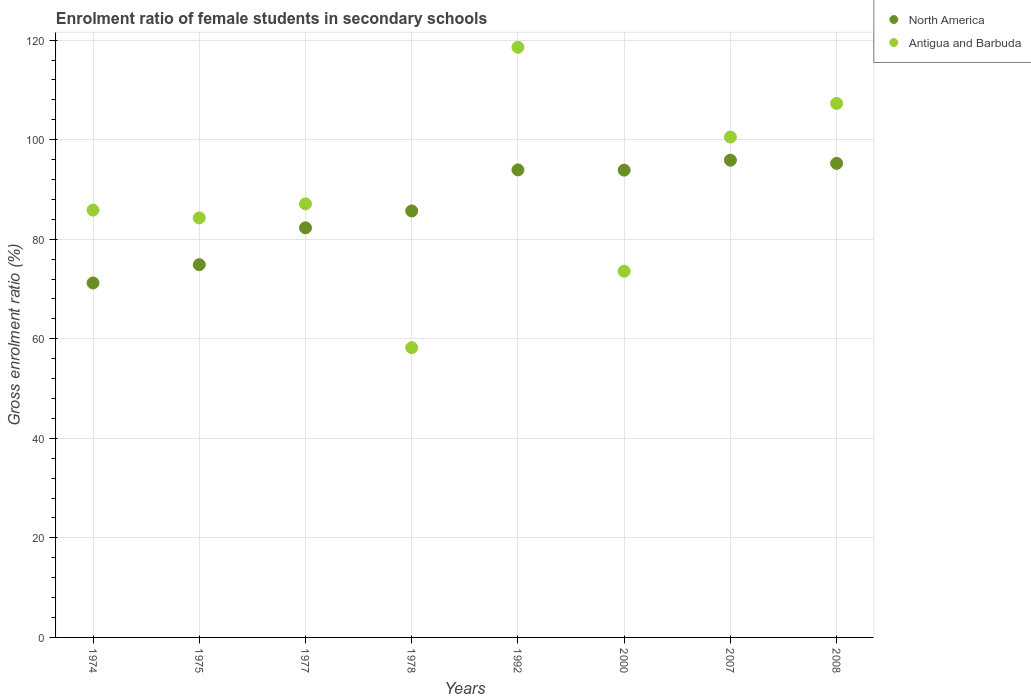Is the number of dotlines equal to the number of legend labels?
Your answer should be very brief. Yes. What is the enrolment ratio of female students in secondary schools in Antigua and Barbuda in 1977?
Your answer should be compact. 87.11. Across all years, what is the maximum enrolment ratio of female students in secondary schools in Antigua and Barbuda?
Offer a very short reply. 118.57. Across all years, what is the minimum enrolment ratio of female students in secondary schools in Antigua and Barbuda?
Give a very brief answer. 58.22. In which year was the enrolment ratio of female students in secondary schools in North America maximum?
Offer a terse response. 2007. In which year was the enrolment ratio of female students in secondary schools in Antigua and Barbuda minimum?
Make the answer very short. 1978. What is the total enrolment ratio of female students in secondary schools in North America in the graph?
Offer a very short reply. 693.03. What is the difference between the enrolment ratio of female students in secondary schools in Antigua and Barbuda in 1977 and that in 1992?
Your response must be concise. -31.46. What is the difference between the enrolment ratio of female students in secondary schools in North America in 1978 and the enrolment ratio of female students in secondary schools in Antigua and Barbuda in 1977?
Offer a terse response. -1.43. What is the average enrolment ratio of female students in secondary schools in Antigua and Barbuda per year?
Your response must be concise. 89.43. In the year 2008, what is the difference between the enrolment ratio of female students in secondary schools in Antigua and Barbuda and enrolment ratio of female students in secondary schools in North America?
Provide a short and direct response. 12.04. In how many years, is the enrolment ratio of female students in secondary schools in North America greater than 40 %?
Make the answer very short. 8. What is the ratio of the enrolment ratio of female students in secondary schools in North America in 1992 to that in 2000?
Provide a short and direct response. 1. Is the difference between the enrolment ratio of female students in secondary schools in Antigua and Barbuda in 1978 and 2007 greater than the difference between the enrolment ratio of female students in secondary schools in North America in 1978 and 2007?
Provide a short and direct response. No. What is the difference between the highest and the second highest enrolment ratio of female students in secondary schools in North America?
Make the answer very short. 0.64. What is the difference between the highest and the lowest enrolment ratio of female students in secondary schools in Antigua and Barbuda?
Provide a short and direct response. 60.35. In how many years, is the enrolment ratio of female students in secondary schools in Antigua and Barbuda greater than the average enrolment ratio of female students in secondary schools in Antigua and Barbuda taken over all years?
Offer a very short reply. 3. Is the enrolment ratio of female students in secondary schools in Antigua and Barbuda strictly less than the enrolment ratio of female students in secondary schools in North America over the years?
Give a very brief answer. No. How many years are there in the graph?
Keep it short and to the point. 8. What is the difference between two consecutive major ticks on the Y-axis?
Provide a short and direct response. 20. Are the values on the major ticks of Y-axis written in scientific E-notation?
Make the answer very short. No. Does the graph contain any zero values?
Ensure brevity in your answer.  No. Does the graph contain grids?
Give a very brief answer. Yes. How many legend labels are there?
Ensure brevity in your answer.  2. How are the legend labels stacked?
Offer a terse response. Vertical. What is the title of the graph?
Offer a terse response. Enrolment ratio of female students in secondary schools. Does "Montenegro" appear as one of the legend labels in the graph?
Your answer should be very brief. No. What is the label or title of the X-axis?
Your answer should be very brief. Years. What is the label or title of the Y-axis?
Make the answer very short. Gross enrolment ratio (%). What is the Gross enrolment ratio (%) in North America in 1974?
Offer a very short reply. 71.22. What is the Gross enrolment ratio (%) in Antigua and Barbuda in 1974?
Ensure brevity in your answer.  85.86. What is the Gross enrolment ratio (%) in North America in 1975?
Offer a very short reply. 74.89. What is the Gross enrolment ratio (%) of Antigua and Barbuda in 1975?
Offer a terse response. 84.29. What is the Gross enrolment ratio (%) of North America in 1977?
Provide a short and direct response. 82.29. What is the Gross enrolment ratio (%) of Antigua and Barbuda in 1977?
Offer a terse response. 87.11. What is the Gross enrolment ratio (%) of North America in 1978?
Keep it short and to the point. 85.68. What is the Gross enrolment ratio (%) in Antigua and Barbuda in 1978?
Keep it short and to the point. 58.22. What is the Gross enrolment ratio (%) in North America in 1992?
Give a very brief answer. 93.93. What is the Gross enrolment ratio (%) of Antigua and Barbuda in 1992?
Provide a short and direct response. 118.57. What is the Gross enrolment ratio (%) in North America in 2000?
Offer a very short reply. 93.89. What is the Gross enrolment ratio (%) of Antigua and Barbuda in 2000?
Provide a succinct answer. 73.58. What is the Gross enrolment ratio (%) in North America in 2007?
Offer a terse response. 95.88. What is the Gross enrolment ratio (%) of Antigua and Barbuda in 2007?
Your answer should be very brief. 100.53. What is the Gross enrolment ratio (%) in North America in 2008?
Provide a short and direct response. 95.24. What is the Gross enrolment ratio (%) in Antigua and Barbuda in 2008?
Offer a very short reply. 107.28. Across all years, what is the maximum Gross enrolment ratio (%) in North America?
Provide a succinct answer. 95.88. Across all years, what is the maximum Gross enrolment ratio (%) in Antigua and Barbuda?
Give a very brief answer. 118.57. Across all years, what is the minimum Gross enrolment ratio (%) in North America?
Provide a succinct answer. 71.22. Across all years, what is the minimum Gross enrolment ratio (%) of Antigua and Barbuda?
Your answer should be very brief. 58.22. What is the total Gross enrolment ratio (%) in North America in the graph?
Make the answer very short. 693.03. What is the total Gross enrolment ratio (%) in Antigua and Barbuda in the graph?
Make the answer very short. 715.44. What is the difference between the Gross enrolment ratio (%) in North America in 1974 and that in 1975?
Keep it short and to the point. -3.67. What is the difference between the Gross enrolment ratio (%) in Antigua and Barbuda in 1974 and that in 1975?
Give a very brief answer. 1.57. What is the difference between the Gross enrolment ratio (%) in North America in 1974 and that in 1977?
Keep it short and to the point. -11.08. What is the difference between the Gross enrolment ratio (%) in Antigua and Barbuda in 1974 and that in 1977?
Offer a very short reply. -1.25. What is the difference between the Gross enrolment ratio (%) in North America in 1974 and that in 1978?
Make the answer very short. -14.47. What is the difference between the Gross enrolment ratio (%) in Antigua and Barbuda in 1974 and that in 1978?
Your response must be concise. 27.64. What is the difference between the Gross enrolment ratio (%) in North America in 1974 and that in 1992?
Your response must be concise. -22.72. What is the difference between the Gross enrolment ratio (%) of Antigua and Barbuda in 1974 and that in 1992?
Ensure brevity in your answer.  -32.71. What is the difference between the Gross enrolment ratio (%) of North America in 1974 and that in 2000?
Your answer should be very brief. -22.67. What is the difference between the Gross enrolment ratio (%) of Antigua and Barbuda in 1974 and that in 2000?
Your response must be concise. 12.28. What is the difference between the Gross enrolment ratio (%) in North America in 1974 and that in 2007?
Your answer should be compact. -24.67. What is the difference between the Gross enrolment ratio (%) in Antigua and Barbuda in 1974 and that in 2007?
Ensure brevity in your answer.  -14.67. What is the difference between the Gross enrolment ratio (%) in North America in 1974 and that in 2008?
Your answer should be very brief. -24.03. What is the difference between the Gross enrolment ratio (%) in Antigua and Barbuda in 1974 and that in 2008?
Your answer should be very brief. -21.42. What is the difference between the Gross enrolment ratio (%) of North America in 1975 and that in 1977?
Keep it short and to the point. -7.4. What is the difference between the Gross enrolment ratio (%) of Antigua and Barbuda in 1975 and that in 1977?
Your answer should be very brief. -2.82. What is the difference between the Gross enrolment ratio (%) of North America in 1975 and that in 1978?
Provide a succinct answer. -10.79. What is the difference between the Gross enrolment ratio (%) in Antigua and Barbuda in 1975 and that in 1978?
Offer a terse response. 26.07. What is the difference between the Gross enrolment ratio (%) of North America in 1975 and that in 1992?
Make the answer very short. -19.04. What is the difference between the Gross enrolment ratio (%) of Antigua and Barbuda in 1975 and that in 1992?
Give a very brief answer. -34.28. What is the difference between the Gross enrolment ratio (%) in North America in 1975 and that in 2000?
Offer a very short reply. -19. What is the difference between the Gross enrolment ratio (%) of Antigua and Barbuda in 1975 and that in 2000?
Your response must be concise. 10.71. What is the difference between the Gross enrolment ratio (%) of North America in 1975 and that in 2007?
Provide a short and direct response. -20.99. What is the difference between the Gross enrolment ratio (%) in Antigua and Barbuda in 1975 and that in 2007?
Give a very brief answer. -16.24. What is the difference between the Gross enrolment ratio (%) in North America in 1975 and that in 2008?
Provide a short and direct response. -20.35. What is the difference between the Gross enrolment ratio (%) in Antigua and Barbuda in 1975 and that in 2008?
Make the answer very short. -23. What is the difference between the Gross enrolment ratio (%) in North America in 1977 and that in 1978?
Offer a very short reply. -3.39. What is the difference between the Gross enrolment ratio (%) of Antigua and Barbuda in 1977 and that in 1978?
Ensure brevity in your answer.  28.89. What is the difference between the Gross enrolment ratio (%) in North America in 1977 and that in 1992?
Offer a very short reply. -11.64. What is the difference between the Gross enrolment ratio (%) of Antigua and Barbuda in 1977 and that in 1992?
Provide a short and direct response. -31.46. What is the difference between the Gross enrolment ratio (%) of North America in 1977 and that in 2000?
Provide a short and direct response. -11.59. What is the difference between the Gross enrolment ratio (%) in Antigua and Barbuda in 1977 and that in 2000?
Make the answer very short. 13.53. What is the difference between the Gross enrolment ratio (%) in North America in 1977 and that in 2007?
Offer a very short reply. -13.59. What is the difference between the Gross enrolment ratio (%) in Antigua and Barbuda in 1977 and that in 2007?
Provide a succinct answer. -13.42. What is the difference between the Gross enrolment ratio (%) of North America in 1977 and that in 2008?
Your response must be concise. -12.95. What is the difference between the Gross enrolment ratio (%) in Antigua and Barbuda in 1977 and that in 2008?
Give a very brief answer. -20.18. What is the difference between the Gross enrolment ratio (%) of North America in 1978 and that in 1992?
Provide a short and direct response. -8.25. What is the difference between the Gross enrolment ratio (%) of Antigua and Barbuda in 1978 and that in 1992?
Ensure brevity in your answer.  -60.35. What is the difference between the Gross enrolment ratio (%) of North America in 1978 and that in 2000?
Keep it short and to the point. -8.2. What is the difference between the Gross enrolment ratio (%) of Antigua and Barbuda in 1978 and that in 2000?
Keep it short and to the point. -15.36. What is the difference between the Gross enrolment ratio (%) in North America in 1978 and that in 2007?
Keep it short and to the point. -10.2. What is the difference between the Gross enrolment ratio (%) in Antigua and Barbuda in 1978 and that in 2007?
Your response must be concise. -42.3. What is the difference between the Gross enrolment ratio (%) in North America in 1978 and that in 2008?
Offer a terse response. -9.56. What is the difference between the Gross enrolment ratio (%) of Antigua and Barbuda in 1978 and that in 2008?
Provide a short and direct response. -49.06. What is the difference between the Gross enrolment ratio (%) of North America in 1992 and that in 2000?
Your answer should be compact. 0.05. What is the difference between the Gross enrolment ratio (%) in Antigua and Barbuda in 1992 and that in 2000?
Your answer should be very brief. 44.99. What is the difference between the Gross enrolment ratio (%) in North America in 1992 and that in 2007?
Keep it short and to the point. -1.95. What is the difference between the Gross enrolment ratio (%) of Antigua and Barbuda in 1992 and that in 2007?
Provide a succinct answer. 18.04. What is the difference between the Gross enrolment ratio (%) of North America in 1992 and that in 2008?
Offer a very short reply. -1.31. What is the difference between the Gross enrolment ratio (%) of Antigua and Barbuda in 1992 and that in 2008?
Offer a terse response. 11.29. What is the difference between the Gross enrolment ratio (%) in North America in 2000 and that in 2007?
Your response must be concise. -2. What is the difference between the Gross enrolment ratio (%) in Antigua and Barbuda in 2000 and that in 2007?
Provide a succinct answer. -26.95. What is the difference between the Gross enrolment ratio (%) of North America in 2000 and that in 2008?
Ensure brevity in your answer.  -1.36. What is the difference between the Gross enrolment ratio (%) in Antigua and Barbuda in 2000 and that in 2008?
Offer a terse response. -33.71. What is the difference between the Gross enrolment ratio (%) of North America in 2007 and that in 2008?
Ensure brevity in your answer.  0.64. What is the difference between the Gross enrolment ratio (%) of Antigua and Barbuda in 2007 and that in 2008?
Make the answer very short. -6.76. What is the difference between the Gross enrolment ratio (%) in North America in 1974 and the Gross enrolment ratio (%) in Antigua and Barbuda in 1975?
Provide a succinct answer. -13.07. What is the difference between the Gross enrolment ratio (%) in North America in 1974 and the Gross enrolment ratio (%) in Antigua and Barbuda in 1977?
Make the answer very short. -15.89. What is the difference between the Gross enrolment ratio (%) of North America in 1974 and the Gross enrolment ratio (%) of Antigua and Barbuda in 1978?
Keep it short and to the point. 12.99. What is the difference between the Gross enrolment ratio (%) of North America in 1974 and the Gross enrolment ratio (%) of Antigua and Barbuda in 1992?
Your response must be concise. -47.36. What is the difference between the Gross enrolment ratio (%) in North America in 1974 and the Gross enrolment ratio (%) in Antigua and Barbuda in 2000?
Provide a short and direct response. -2.36. What is the difference between the Gross enrolment ratio (%) of North America in 1974 and the Gross enrolment ratio (%) of Antigua and Barbuda in 2007?
Provide a succinct answer. -29.31. What is the difference between the Gross enrolment ratio (%) of North America in 1974 and the Gross enrolment ratio (%) of Antigua and Barbuda in 2008?
Your response must be concise. -36.07. What is the difference between the Gross enrolment ratio (%) in North America in 1975 and the Gross enrolment ratio (%) in Antigua and Barbuda in 1977?
Provide a succinct answer. -12.22. What is the difference between the Gross enrolment ratio (%) of North America in 1975 and the Gross enrolment ratio (%) of Antigua and Barbuda in 1978?
Your response must be concise. 16.67. What is the difference between the Gross enrolment ratio (%) in North America in 1975 and the Gross enrolment ratio (%) in Antigua and Barbuda in 1992?
Keep it short and to the point. -43.68. What is the difference between the Gross enrolment ratio (%) of North America in 1975 and the Gross enrolment ratio (%) of Antigua and Barbuda in 2000?
Offer a very short reply. 1.31. What is the difference between the Gross enrolment ratio (%) of North America in 1975 and the Gross enrolment ratio (%) of Antigua and Barbuda in 2007?
Provide a succinct answer. -25.64. What is the difference between the Gross enrolment ratio (%) of North America in 1975 and the Gross enrolment ratio (%) of Antigua and Barbuda in 2008?
Ensure brevity in your answer.  -32.4. What is the difference between the Gross enrolment ratio (%) of North America in 1977 and the Gross enrolment ratio (%) of Antigua and Barbuda in 1978?
Offer a terse response. 24.07. What is the difference between the Gross enrolment ratio (%) of North America in 1977 and the Gross enrolment ratio (%) of Antigua and Barbuda in 1992?
Provide a succinct answer. -36.28. What is the difference between the Gross enrolment ratio (%) in North America in 1977 and the Gross enrolment ratio (%) in Antigua and Barbuda in 2000?
Provide a succinct answer. 8.72. What is the difference between the Gross enrolment ratio (%) in North America in 1977 and the Gross enrolment ratio (%) in Antigua and Barbuda in 2007?
Your answer should be very brief. -18.23. What is the difference between the Gross enrolment ratio (%) in North America in 1977 and the Gross enrolment ratio (%) in Antigua and Barbuda in 2008?
Keep it short and to the point. -24.99. What is the difference between the Gross enrolment ratio (%) in North America in 1978 and the Gross enrolment ratio (%) in Antigua and Barbuda in 1992?
Provide a short and direct response. -32.89. What is the difference between the Gross enrolment ratio (%) in North America in 1978 and the Gross enrolment ratio (%) in Antigua and Barbuda in 2000?
Your answer should be very brief. 12.1. What is the difference between the Gross enrolment ratio (%) of North America in 1978 and the Gross enrolment ratio (%) of Antigua and Barbuda in 2007?
Your response must be concise. -14.85. What is the difference between the Gross enrolment ratio (%) of North America in 1978 and the Gross enrolment ratio (%) of Antigua and Barbuda in 2008?
Keep it short and to the point. -21.6. What is the difference between the Gross enrolment ratio (%) in North America in 1992 and the Gross enrolment ratio (%) in Antigua and Barbuda in 2000?
Give a very brief answer. 20.36. What is the difference between the Gross enrolment ratio (%) in North America in 1992 and the Gross enrolment ratio (%) in Antigua and Barbuda in 2007?
Offer a terse response. -6.59. What is the difference between the Gross enrolment ratio (%) in North America in 1992 and the Gross enrolment ratio (%) in Antigua and Barbuda in 2008?
Offer a terse response. -13.35. What is the difference between the Gross enrolment ratio (%) of North America in 2000 and the Gross enrolment ratio (%) of Antigua and Barbuda in 2007?
Give a very brief answer. -6.64. What is the difference between the Gross enrolment ratio (%) in North America in 2000 and the Gross enrolment ratio (%) in Antigua and Barbuda in 2008?
Make the answer very short. -13.4. What is the difference between the Gross enrolment ratio (%) in North America in 2007 and the Gross enrolment ratio (%) in Antigua and Barbuda in 2008?
Your answer should be very brief. -11.4. What is the average Gross enrolment ratio (%) in North America per year?
Offer a terse response. 86.63. What is the average Gross enrolment ratio (%) of Antigua and Barbuda per year?
Your answer should be very brief. 89.43. In the year 1974, what is the difference between the Gross enrolment ratio (%) of North America and Gross enrolment ratio (%) of Antigua and Barbuda?
Provide a succinct answer. -14.64. In the year 1975, what is the difference between the Gross enrolment ratio (%) of North America and Gross enrolment ratio (%) of Antigua and Barbuda?
Your answer should be compact. -9.4. In the year 1977, what is the difference between the Gross enrolment ratio (%) of North America and Gross enrolment ratio (%) of Antigua and Barbuda?
Ensure brevity in your answer.  -4.81. In the year 1978, what is the difference between the Gross enrolment ratio (%) in North America and Gross enrolment ratio (%) in Antigua and Barbuda?
Keep it short and to the point. 27.46. In the year 1992, what is the difference between the Gross enrolment ratio (%) of North America and Gross enrolment ratio (%) of Antigua and Barbuda?
Your response must be concise. -24.64. In the year 2000, what is the difference between the Gross enrolment ratio (%) of North America and Gross enrolment ratio (%) of Antigua and Barbuda?
Keep it short and to the point. 20.31. In the year 2007, what is the difference between the Gross enrolment ratio (%) in North America and Gross enrolment ratio (%) in Antigua and Barbuda?
Offer a terse response. -4.64. In the year 2008, what is the difference between the Gross enrolment ratio (%) in North America and Gross enrolment ratio (%) in Antigua and Barbuda?
Provide a short and direct response. -12.04. What is the ratio of the Gross enrolment ratio (%) in North America in 1974 to that in 1975?
Give a very brief answer. 0.95. What is the ratio of the Gross enrolment ratio (%) in Antigua and Barbuda in 1974 to that in 1975?
Keep it short and to the point. 1.02. What is the ratio of the Gross enrolment ratio (%) in North America in 1974 to that in 1977?
Provide a short and direct response. 0.87. What is the ratio of the Gross enrolment ratio (%) in Antigua and Barbuda in 1974 to that in 1977?
Provide a succinct answer. 0.99. What is the ratio of the Gross enrolment ratio (%) of North America in 1974 to that in 1978?
Give a very brief answer. 0.83. What is the ratio of the Gross enrolment ratio (%) in Antigua and Barbuda in 1974 to that in 1978?
Provide a succinct answer. 1.47. What is the ratio of the Gross enrolment ratio (%) of North America in 1974 to that in 1992?
Provide a short and direct response. 0.76. What is the ratio of the Gross enrolment ratio (%) in Antigua and Barbuda in 1974 to that in 1992?
Give a very brief answer. 0.72. What is the ratio of the Gross enrolment ratio (%) of North America in 1974 to that in 2000?
Give a very brief answer. 0.76. What is the ratio of the Gross enrolment ratio (%) of Antigua and Barbuda in 1974 to that in 2000?
Offer a very short reply. 1.17. What is the ratio of the Gross enrolment ratio (%) of North America in 1974 to that in 2007?
Your answer should be very brief. 0.74. What is the ratio of the Gross enrolment ratio (%) in Antigua and Barbuda in 1974 to that in 2007?
Your response must be concise. 0.85. What is the ratio of the Gross enrolment ratio (%) in North America in 1974 to that in 2008?
Keep it short and to the point. 0.75. What is the ratio of the Gross enrolment ratio (%) in Antigua and Barbuda in 1974 to that in 2008?
Your response must be concise. 0.8. What is the ratio of the Gross enrolment ratio (%) in North America in 1975 to that in 1977?
Ensure brevity in your answer.  0.91. What is the ratio of the Gross enrolment ratio (%) of Antigua and Barbuda in 1975 to that in 1977?
Keep it short and to the point. 0.97. What is the ratio of the Gross enrolment ratio (%) of North America in 1975 to that in 1978?
Make the answer very short. 0.87. What is the ratio of the Gross enrolment ratio (%) of Antigua and Barbuda in 1975 to that in 1978?
Your answer should be compact. 1.45. What is the ratio of the Gross enrolment ratio (%) of North America in 1975 to that in 1992?
Provide a short and direct response. 0.8. What is the ratio of the Gross enrolment ratio (%) in Antigua and Barbuda in 1975 to that in 1992?
Ensure brevity in your answer.  0.71. What is the ratio of the Gross enrolment ratio (%) in North America in 1975 to that in 2000?
Your answer should be very brief. 0.8. What is the ratio of the Gross enrolment ratio (%) in Antigua and Barbuda in 1975 to that in 2000?
Give a very brief answer. 1.15. What is the ratio of the Gross enrolment ratio (%) in North America in 1975 to that in 2007?
Ensure brevity in your answer.  0.78. What is the ratio of the Gross enrolment ratio (%) of Antigua and Barbuda in 1975 to that in 2007?
Offer a very short reply. 0.84. What is the ratio of the Gross enrolment ratio (%) of North America in 1975 to that in 2008?
Offer a terse response. 0.79. What is the ratio of the Gross enrolment ratio (%) in Antigua and Barbuda in 1975 to that in 2008?
Offer a terse response. 0.79. What is the ratio of the Gross enrolment ratio (%) of North America in 1977 to that in 1978?
Make the answer very short. 0.96. What is the ratio of the Gross enrolment ratio (%) of Antigua and Barbuda in 1977 to that in 1978?
Provide a short and direct response. 1.5. What is the ratio of the Gross enrolment ratio (%) of North America in 1977 to that in 1992?
Your answer should be very brief. 0.88. What is the ratio of the Gross enrolment ratio (%) of Antigua and Barbuda in 1977 to that in 1992?
Make the answer very short. 0.73. What is the ratio of the Gross enrolment ratio (%) in North America in 1977 to that in 2000?
Your answer should be compact. 0.88. What is the ratio of the Gross enrolment ratio (%) of Antigua and Barbuda in 1977 to that in 2000?
Provide a succinct answer. 1.18. What is the ratio of the Gross enrolment ratio (%) in North America in 1977 to that in 2007?
Provide a succinct answer. 0.86. What is the ratio of the Gross enrolment ratio (%) of Antigua and Barbuda in 1977 to that in 2007?
Ensure brevity in your answer.  0.87. What is the ratio of the Gross enrolment ratio (%) of North America in 1977 to that in 2008?
Your answer should be very brief. 0.86. What is the ratio of the Gross enrolment ratio (%) in Antigua and Barbuda in 1977 to that in 2008?
Make the answer very short. 0.81. What is the ratio of the Gross enrolment ratio (%) of North America in 1978 to that in 1992?
Make the answer very short. 0.91. What is the ratio of the Gross enrolment ratio (%) in Antigua and Barbuda in 1978 to that in 1992?
Your response must be concise. 0.49. What is the ratio of the Gross enrolment ratio (%) of North America in 1978 to that in 2000?
Provide a succinct answer. 0.91. What is the ratio of the Gross enrolment ratio (%) in Antigua and Barbuda in 1978 to that in 2000?
Offer a terse response. 0.79. What is the ratio of the Gross enrolment ratio (%) of North America in 1978 to that in 2007?
Your response must be concise. 0.89. What is the ratio of the Gross enrolment ratio (%) of Antigua and Barbuda in 1978 to that in 2007?
Provide a short and direct response. 0.58. What is the ratio of the Gross enrolment ratio (%) of North America in 1978 to that in 2008?
Keep it short and to the point. 0.9. What is the ratio of the Gross enrolment ratio (%) of Antigua and Barbuda in 1978 to that in 2008?
Your response must be concise. 0.54. What is the ratio of the Gross enrolment ratio (%) of Antigua and Barbuda in 1992 to that in 2000?
Offer a very short reply. 1.61. What is the ratio of the Gross enrolment ratio (%) in North America in 1992 to that in 2007?
Give a very brief answer. 0.98. What is the ratio of the Gross enrolment ratio (%) in Antigua and Barbuda in 1992 to that in 2007?
Your answer should be compact. 1.18. What is the ratio of the Gross enrolment ratio (%) in North America in 1992 to that in 2008?
Keep it short and to the point. 0.99. What is the ratio of the Gross enrolment ratio (%) of Antigua and Barbuda in 1992 to that in 2008?
Your answer should be compact. 1.11. What is the ratio of the Gross enrolment ratio (%) of North America in 2000 to that in 2007?
Your answer should be very brief. 0.98. What is the ratio of the Gross enrolment ratio (%) of Antigua and Barbuda in 2000 to that in 2007?
Offer a very short reply. 0.73. What is the ratio of the Gross enrolment ratio (%) of North America in 2000 to that in 2008?
Give a very brief answer. 0.99. What is the ratio of the Gross enrolment ratio (%) in Antigua and Barbuda in 2000 to that in 2008?
Provide a short and direct response. 0.69. What is the ratio of the Gross enrolment ratio (%) of North America in 2007 to that in 2008?
Your response must be concise. 1.01. What is the ratio of the Gross enrolment ratio (%) of Antigua and Barbuda in 2007 to that in 2008?
Your answer should be very brief. 0.94. What is the difference between the highest and the second highest Gross enrolment ratio (%) in North America?
Offer a terse response. 0.64. What is the difference between the highest and the second highest Gross enrolment ratio (%) in Antigua and Barbuda?
Provide a succinct answer. 11.29. What is the difference between the highest and the lowest Gross enrolment ratio (%) of North America?
Make the answer very short. 24.67. What is the difference between the highest and the lowest Gross enrolment ratio (%) in Antigua and Barbuda?
Give a very brief answer. 60.35. 